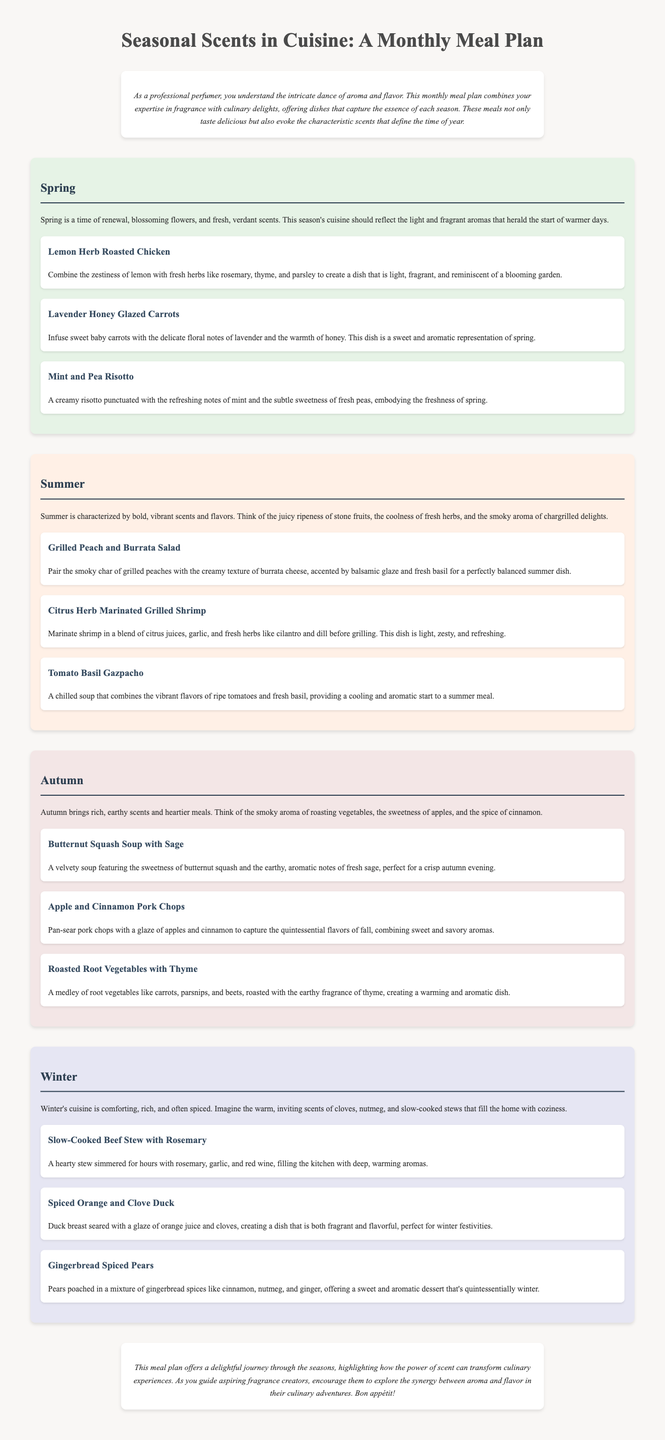What is the title of the document? The title is prominently displayed at the top of the document, indicating the overall theme, which is about a meal plan.
Answer: Seasonal Scents in Cuisine: A Monthly Meal Plan What are the three herbs mentioned in the Lemon Herb Roasted Chicken dish? The herbs mentioned are rosemary, thyme, and parsley, which are combined with lemon for flavor.
Answer: rosemary, thyme, parsley Which dish features the aroma of lavender? The Lavender Honey Glazed Carrots dish is specifically noted for its floral notes of lavender.
Answer: Lavender Honey Glazed Carrots What is a key scent characteristic of summer cuisine? The document describes summer cuisine as having bold and vibrant scents, focusing on the juiciness of stone fruits and fresh herbs.
Answer: bold, vibrant scents How many dishes are suggested for each season? Each season in the meal plan features three dishes that align with its aromatic theme.
Answer: three dishes In which season is the Butternut Squash Soup with Sage served? This dish is specifically mentioned under the autumn section, reflecting the rich flavors of that season.
Answer: autumn What type of meal is recommended for winter festivities? The document suggests a Spiced Orange and Clove Duck as a fragrant and flavorful dish for winter celebrations.
Answer: Spiced Orange and Clove Duck What is the primary theme of the meal plan? The meal plan emphasizes the connection between aroma and cuisine, using seasonal scents to enhance culinary experiences.
Answer: connection between aroma and cuisine What is a signature flavor of the winter dessert? The dessert features gingerbread spices like cinnamon, nutmeg, and ginger, which are characteristic of winter flavors.
Answer: gingerbread spices 